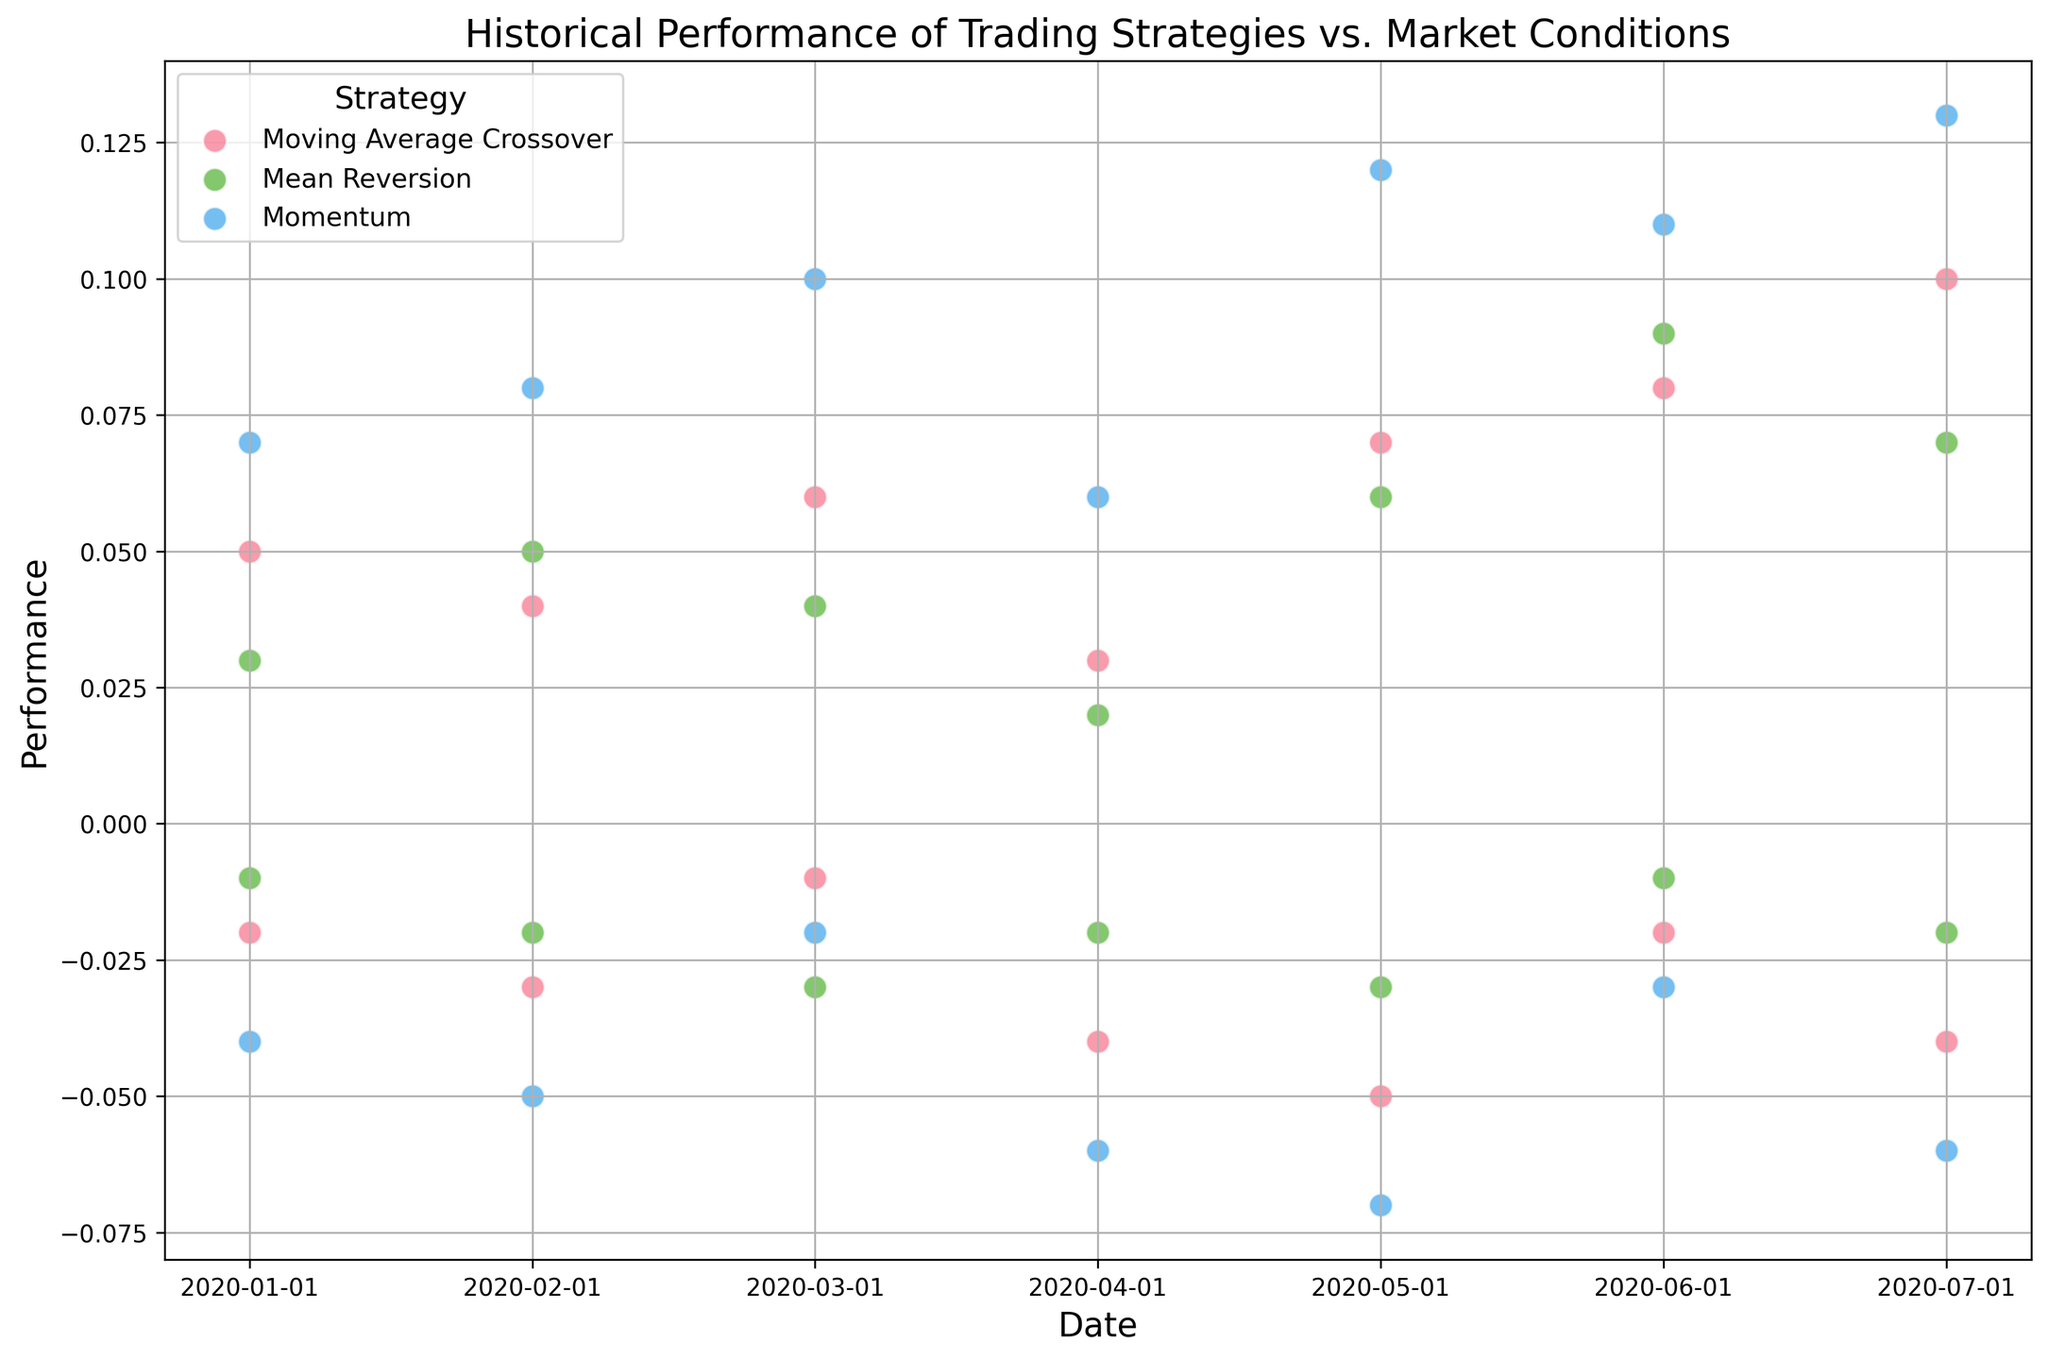What strategy performed the best on average during Bullish market conditions? To answer this question, calculate the average performance for each strategy during Bullish market conditions then compare them. Use the data points for each strategy under the Bullish market condition.
Answer: Momentum What strategy showed the worst performance during Bearish market conditions on May 1, 2020? Check the performance values on May 1, 2020, under Bearish market conditions for each strategy and identify the lowest value.
Answer: Momentum Which strategy has the largest variation in performance across different dates? Examine the range of performance values for each strategy by comparing the highest and lowest performance across all dates. Calculate the difference for each strategy and identify the one with the largest span.
Answer: Momentum Are there dates where all strategies performed positively in Bullish market conditions? If so, which ones? Check the performance values on each date under Bullish market conditions for all three strategies and identify dates where all values are positive.
Answer: Yes, January 1, February 1, March 1, April 1, May 1, June 1, July 1, 2020 How did the performance of the Moving Average Crossover strategy change from Bearish to Bullish market conditions on July 1, 2020? Find the performance values for the Moving Average Crossover strategy on July 1, 2020, under both Bearish and Bullish market conditions and calculate the difference between them.
Answer: Increased by 0.14 Which strategy consistently performed worse in Bearish market conditions? Analyze the performance values of each strategy across all dates under Bearish market conditions and determine which has the most consistently negative values.
Answer: Momentum What is the average performance of the Mean Reversion strategy in Bullish market conditions? Calculate the sum of the performance values for the Mean Reversion strategy under Bullish market conditions and divide by the number of data points. The relevant data points are 0.03, 0.05, 0.04, 0.02, 0.06, 0.09, 0.07.
Answer: 0.051 Between which two dates did the performance of the Momentum strategy in Bullish conditions show the largest increase? Examine the performance values of the Momentum strategy in Bullish conditions across the dates to identify the two consecutive dates with the largest increase.
Answer: February to March Compare the performance of the Moving Average Crossover and Momentum strategies in Bearish market conditions on March 1, 2020. Which one performed better? Check the performance values for both strategies under Bearish market conditions on March 1, 2020, and compare them to determine which one is higher.
Answer: Moving Average Crossover Identify the highest performance value recorded by the Momentum strategy. Which market condition was it under and on what date? Look through the performance data for the Momentum strategy and identify the highest value, then check the corresponding market condition and date.
Answer: 0.13, Bullish, July 1, 2020 